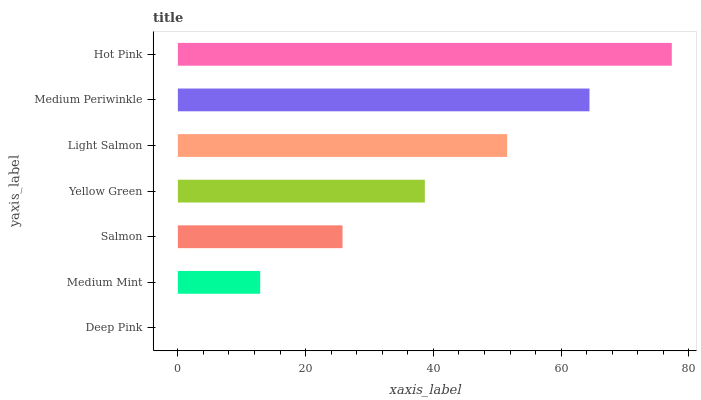Is Deep Pink the minimum?
Answer yes or no. Yes. Is Hot Pink the maximum?
Answer yes or no. Yes. Is Medium Mint the minimum?
Answer yes or no. No. Is Medium Mint the maximum?
Answer yes or no. No. Is Medium Mint greater than Deep Pink?
Answer yes or no. Yes. Is Deep Pink less than Medium Mint?
Answer yes or no. Yes. Is Deep Pink greater than Medium Mint?
Answer yes or no. No. Is Medium Mint less than Deep Pink?
Answer yes or no. No. Is Yellow Green the high median?
Answer yes or no. Yes. Is Yellow Green the low median?
Answer yes or no. Yes. Is Salmon the high median?
Answer yes or no. No. Is Medium Periwinkle the low median?
Answer yes or no. No. 